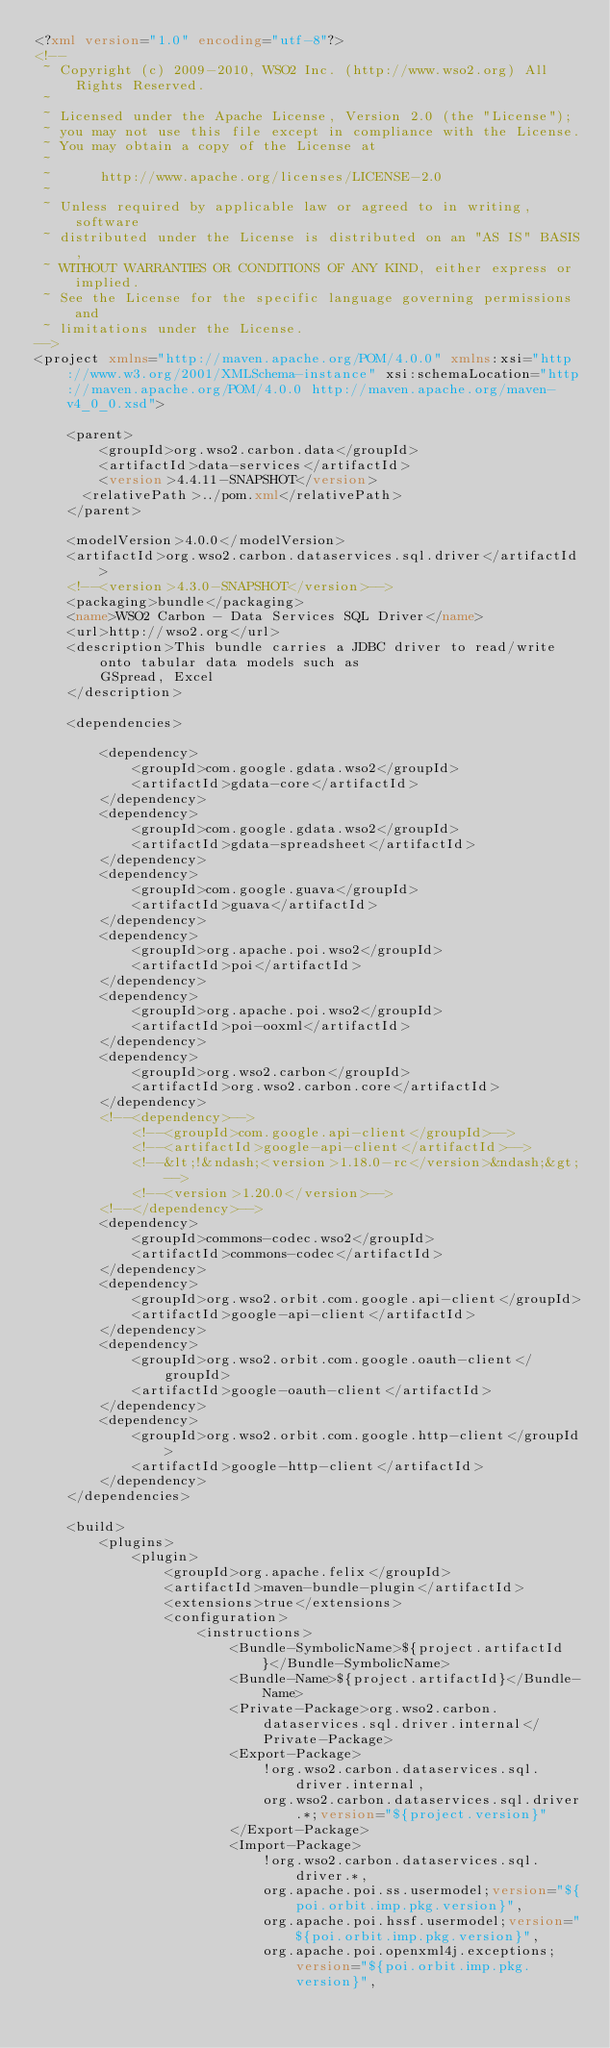Convert code to text. <code><loc_0><loc_0><loc_500><loc_500><_XML_><?xml version="1.0" encoding="utf-8"?>
<!--
 ~ Copyright (c) 2009-2010, WSO2 Inc. (http://www.wso2.org) All Rights Reserved.
 ~
 ~ Licensed under the Apache License, Version 2.0 (the "License");
 ~ you may not use this file except in compliance with the License.
 ~ You may obtain a copy of the License at
 ~
 ~      http://www.apache.org/licenses/LICENSE-2.0
 ~
 ~ Unless required by applicable law or agreed to in writing, software
 ~ distributed under the License is distributed on an "AS IS" BASIS,
 ~ WITHOUT WARRANTIES OR CONDITIONS OF ANY KIND, either express or implied.
 ~ See the License for the specific language governing permissions and
 ~ limitations under the License.
-->
<project xmlns="http://maven.apache.org/POM/4.0.0" xmlns:xsi="http://www.w3.org/2001/XMLSchema-instance" xsi:schemaLocation="http://maven.apache.org/POM/4.0.0 http://maven.apache.org/maven-v4_0_0.xsd">

    <parent>
        <groupId>org.wso2.carbon.data</groupId>
        <artifactId>data-services</artifactId>
        <version>4.4.11-SNAPSHOT</version>
	    <relativePath>../pom.xml</relativePath>
    </parent>

    <modelVersion>4.0.0</modelVersion>
    <artifactId>org.wso2.carbon.dataservices.sql.driver</artifactId>
    <!--<version>4.3.0-SNAPSHOT</version>-->
    <packaging>bundle</packaging>
    <name>WSO2 Carbon - Data Services SQL Driver</name>
    <url>http://wso2.org</url>
    <description>This bundle carries a JDBC driver to read/write onto tabular data models such as
        GSpread, Excel
    </description>

    <dependencies>

        <dependency>
            <groupId>com.google.gdata.wso2</groupId>
            <artifactId>gdata-core</artifactId>
        </dependency>
        <dependency>
            <groupId>com.google.gdata.wso2</groupId>
            <artifactId>gdata-spreadsheet</artifactId>
        </dependency>
        <dependency>
            <groupId>com.google.guava</groupId>
            <artifactId>guava</artifactId>
        </dependency>
        <dependency>
            <groupId>org.apache.poi.wso2</groupId>
            <artifactId>poi</artifactId>
        </dependency>
        <dependency>
            <groupId>org.apache.poi.wso2</groupId>
            <artifactId>poi-ooxml</artifactId>
        </dependency>
        <dependency>
            <groupId>org.wso2.carbon</groupId>
            <artifactId>org.wso2.carbon.core</artifactId>
        </dependency>
        <!--<dependency>-->
            <!--<groupId>com.google.api-client</groupId>-->
            <!--<artifactId>google-api-client</artifactId>-->
            <!--&lt;!&ndash;<version>1.18.0-rc</version>&ndash;&gt;-->
            <!--<version>1.20.0</version>-->
        <!--</dependency>-->
        <dependency>
            <groupId>commons-codec.wso2</groupId>
            <artifactId>commons-codec</artifactId>
        </dependency>
        <dependency>
            <groupId>org.wso2.orbit.com.google.api-client</groupId>
            <artifactId>google-api-client</artifactId>
        </dependency>
        <dependency>
            <groupId>org.wso2.orbit.com.google.oauth-client</groupId>
            <artifactId>google-oauth-client</artifactId>
        </dependency>
        <dependency>
            <groupId>org.wso2.orbit.com.google.http-client</groupId>
            <artifactId>google-http-client</artifactId>
        </dependency>
    </dependencies>

    <build>
        <plugins>
            <plugin>
                <groupId>org.apache.felix</groupId>
                <artifactId>maven-bundle-plugin</artifactId>
                <extensions>true</extensions>
                <configuration>
                    <instructions>
                        <Bundle-SymbolicName>${project.artifactId}</Bundle-SymbolicName>
                        <Bundle-Name>${project.artifactId}</Bundle-Name>
                        <Private-Package>org.wso2.carbon.dataservices.sql.driver.internal</Private-Package>
                        <Export-Package>
                            !org.wso2.carbon.dataservices.sql.driver.internal,
                            org.wso2.carbon.dataservices.sql.driver.*;version="${project.version}"
                        </Export-Package>
                        <Import-Package>
                            !org.wso2.carbon.dataservices.sql.driver.*,
                            org.apache.poi.ss.usermodel;version="${poi.orbit.imp.pkg.version}",
                            org.apache.poi.hssf.usermodel;version="${poi.orbit.imp.pkg.version}",
                            org.apache.poi.openxml4j.exceptions;version="${poi.orbit.imp.pkg.version}",</code> 